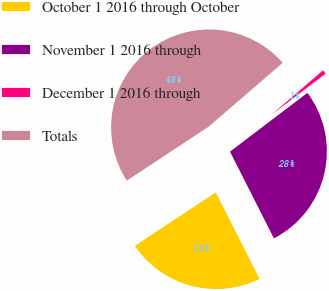Convert chart. <chart><loc_0><loc_0><loc_500><loc_500><pie_chart><fcel>October 1 2016 through October<fcel>November 1 2016 through<fcel>December 1 2016 through<fcel>Totals<nl><fcel>23.18%<fcel>27.88%<fcel>0.98%<fcel>47.96%<nl></chart> 